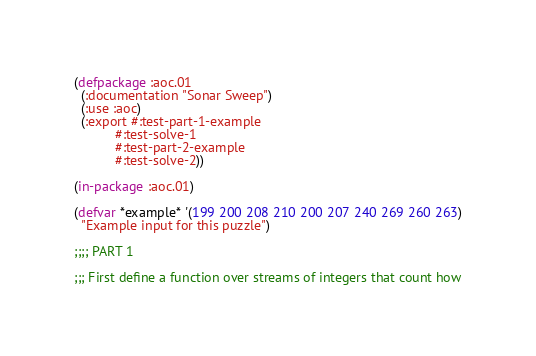Convert code to text. <code><loc_0><loc_0><loc_500><loc_500><_Lisp_>(defpackage :aoc.01
  (:documentation "Sonar Sweep")
  (:use :aoc)
  (:export #:test-part-1-example
           #:test-solve-1
           #:test-part-2-example
           #:test-solve-2))

(in-package :aoc.01)

(defvar *example* '(199 200 208 210 200 207 240 269 260 263)
  "Example input for this puzzle")

;;;; PART 1

;;; First define a function over streams of integers that count how</code> 